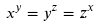Convert formula to latex. <formula><loc_0><loc_0><loc_500><loc_500>x ^ { y } = y ^ { z } = z ^ { x }</formula> 